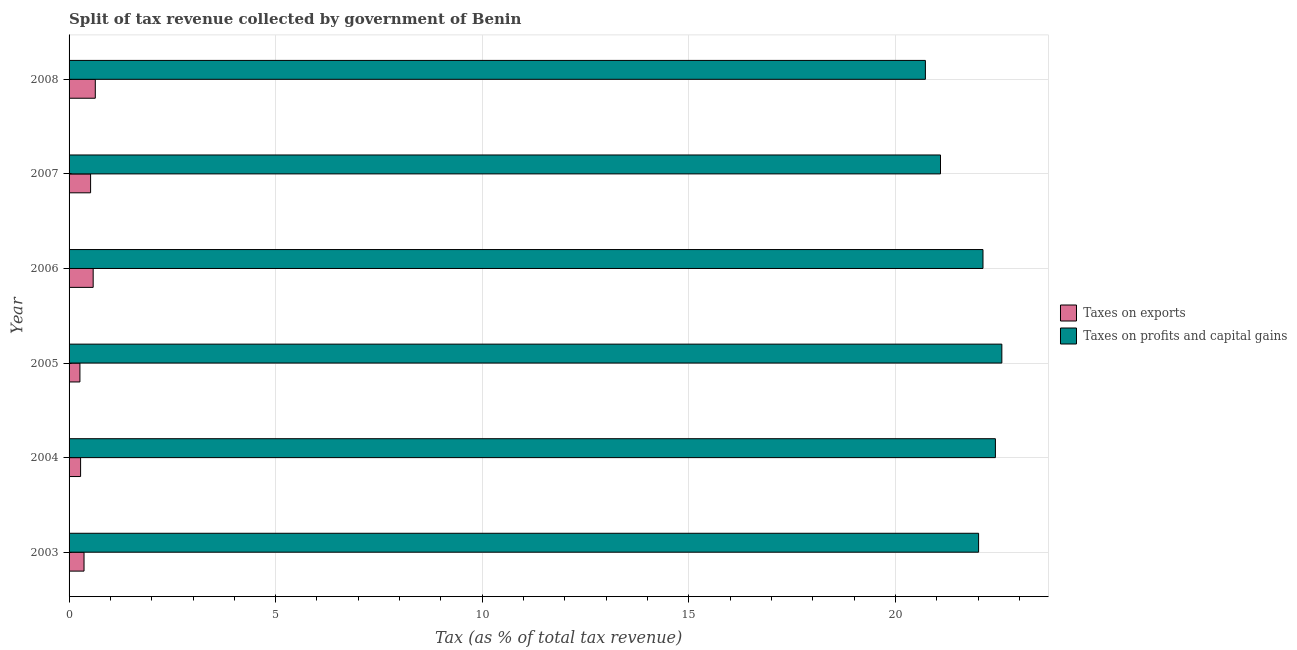How many groups of bars are there?
Ensure brevity in your answer.  6. Are the number of bars per tick equal to the number of legend labels?
Give a very brief answer. Yes. Are the number of bars on each tick of the Y-axis equal?
Offer a very short reply. Yes. How many bars are there on the 4th tick from the bottom?
Your answer should be compact. 2. In how many cases, is the number of bars for a given year not equal to the number of legend labels?
Your response must be concise. 0. What is the percentage of revenue obtained from taxes on exports in 2004?
Keep it short and to the point. 0.28. Across all years, what is the maximum percentage of revenue obtained from taxes on exports?
Provide a succinct answer. 0.63. Across all years, what is the minimum percentage of revenue obtained from taxes on exports?
Offer a terse response. 0.26. In which year was the percentage of revenue obtained from taxes on profits and capital gains maximum?
Your answer should be compact. 2005. In which year was the percentage of revenue obtained from taxes on profits and capital gains minimum?
Give a very brief answer. 2008. What is the total percentage of revenue obtained from taxes on exports in the graph?
Your answer should be very brief. 2.64. What is the difference between the percentage of revenue obtained from taxes on exports in 2003 and that in 2006?
Offer a very short reply. -0.22. What is the difference between the percentage of revenue obtained from taxes on profits and capital gains in 2008 and the percentage of revenue obtained from taxes on exports in 2007?
Keep it short and to the point. 20.2. What is the average percentage of revenue obtained from taxes on profits and capital gains per year?
Your answer should be compact. 21.82. In the year 2007, what is the difference between the percentage of revenue obtained from taxes on exports and percentage of revenue obtained from taxes on profits and capital gains?
Provide a succinct answer. -20.57. What is the ratio of the percentage of revenue obtained from taxes on profits and capital gains in 2006 to that in 2007?
Offer a very short reply. 1.05. Is the percentage of revenue obtained from taxes on exports in 2003 less than that in 2005?
Offer a terse response. No. What is the difference between the highest and the second highest percentage of revenue obtained from taxes on profits and capital gains?
Offer a very short reply. 0.16. What is the difference between the highest and the lowest percentage of revenue obtained from taxes on profits and capital gains?
Provide a succinct answer. 1.85. In how many years, is the percentage of revenue obtained from taxes on profits and capital gains greater than the average percentage of revenue obtained from taxes on profits and capital gains taken over all years?
Offer a terse response. 4. What does the 2nd bar from the top in 2004 represents?
Give a very brief answer. Taxes on exports. What does the 2nd bar from the bottom in 2008 represents?
Your response must be concise. Taxes on profits and capital gains. Are all the bars in the graph horizontal?
Your answer should be compact. Yes. Are the values on the major ticks of X-axis written in scientific E-notation?
Make the answer very short. No. Does the graph contain any zero values?
Give a very brief answer. No. Does the graph contain grids?
Keep it short and to the point. Yes. How many legend labels are there?
Keep it short and to the point. 2. What is the title of the graph?
Provide a succinct answer. Split of tax revenue collected by government of Benin. Does "Nitrous oxide" appear as one of the legend labels in the graph?
Your answer should be compact. No. What is the label or title of the X-axis?
Offer a very short reply. Tax (as % of total tax revenue). What is the Tax (as % of total tax revenue) of Taxes on exports in 2003?
Make the answer very short. 0.36. What is the Tax (as % of total tax revenue) in Taxes on profits and capital gains in 2003?
Provide a short and direct response. 22.01. What is the Tax (as % of total tax revenue) in Taxes on exports in 2004?
Your answer should be very brief. 0.28. What is the Tax (as % of total tax revenue) in Taxes on profits and capital gains in 2004?
Keep it short and to the point. 22.42. What is the Tax (as % of total tax revenue) of Taxes on exports in 2005?
Keep it short and to the point. 0.26. What is the Tax (as % of total tax revenue) of Taxes on profits and capital gains in 2005?
Ensure brevity in your answer.  22.58. What is the Tax (as % of total tax revenue) in Taxes on exports in 2006?
Offer a very short reply. 0.58. What is the Tax (as % of total tax revenue) of Taxes on profits and capital gains in 2006?
Provide a short and direct response. 22.12. What is the Tax (as % of total tax revenue) in Taxes on exports in 2007?
Offer a very short reply. 0.52. What is the Tax (as % of total tax revenue) of Taxes on profits and capital gains in 2007?
Give a very brief answer. 21.09. What is the Tax (as % of total tax revenue) in Taxes on exports in 2008?
Offer a terse response. 0.63. What is the Tax (as % of total tax revenue) of Taxes on profits and capital gains in 2008?
Provide a short and direct response. 20.73. Across all years, what is the maximum Tax (as % of total tax revenue) of Taxes on exports?
Ensure brevity in your answer.  0.63. Across all years, what is the maximum Tax (as % of total tax revenue) in Taxes on profits and capital gains?
Your response must be concise. 22.58. Across all years, what is the minimum Tax (as % of total tax revenue) of Taxes on exports?
Offer a very short reply. 0.26. Across all years, what is the minimum Tax (as % of total tax revenue) of Taxes on profits and capital gains?
Keep it short and to the point. 20.73. What is the total Tax (as % of total tax revenue) in Taxes on exports in the graph?
Give a very brief answer. 2.64. What is the total Tax (as % of total tax revenue) of Taxes on profits and capital gains in the graph?
Your answer should be compact. 130.94. What is the difference between the Tax (as % of total tax revenue) in Taxes on exports in 2003 and that in 2004?
Give a very brief answer. 0.08. What is the difference between the Tax (as % of total tax revenue) of Taxes on profits and capital gains in 2003 and that in 2004?
Your answer should be very brief. -0.41. What is the difference between the Tax (as % of total tax revenue) of Taxes on exports in 2003 and that in 2005?
Your response must be concise. 0.1. What is the difference between the Tax (as % of total tax revenue) in Taxes on profits and capital gains in 2003 and that in 2005?
Keep it short and to the point. -0.56. What is the difference between the Tax (as % of total tax revenue) in Taxes on exports in 2003 and that in 2006?
Your answer should be very brief. -0.22. What is the difference between the Tax (as % of total tax revenue) of Taxes on profits and capital gains in 2003 and that in 2006?
Ensure brevity in your answer.  -0.11. What is the difference between the Tax (as % of total tax revenue) of Taxes on exports in 2003 and that in 2007?
Give a very brief answer. -0.16. What is the difference between the Tax (as % of total tax revenue) of Taxes on profits and capital gains in 2003 and that in 2007?
Give a very brief answer. 0.92. What is the difference between the Tax (as % of total tax revenue) in Taxes on exports in 2003 and that in 2008?
Provide a short and direct response. -0.27. What is the difference between the Tax (as % of total tax revenue) of Taxes on profits and capital gains in 2003 and that in 2008?
Ensure brevity in your answer.  1.29. What is the difference between the Tax (as % of total tax revenue) of Taxes on exports in 2004 and that in 2005?
Keep it short and to the point. 0.02. What is the difference between the Tax (as % of total tax revenue) in Taxes on profits and capital gains in 2004 and that in 2005?
Your answer should be very brief. -0.16. What is the difference between the Tax (as % of total tax revenue) of Taxes on exports in 2004 and that in 2006?
Provide a succinct answer. -0.3. What is the difference between the Tax (as % of total tax revenue) of Taxes on profits and capital gains in 2004 and that in 2006?
Offer a very short reply. 0.3. What is the difference between the Tax (as % of total tax revenue) in Taxes on exports in 2004 and that in 2007?
Offer a terse response. -0.24. What is the difference between the Tax (as % of total tax revenue) of Taxes on profits and capital gains in 2004 and that in 2007?
Make the answer very short. 1.33. What is the difference between the Tax (as % of total tax revenue) of Taxes on exports in 2004 and that in 2008?
Keep it short and to the point. -0.36. What is the difference between the Tax (as % of total tax revenue) of Taxes on profits and capital gains in 2004 and that in 2008?
Provide a short and direct response. 1.69. What is the difference between the Tax (as % of total tax revenue) of Taxes on exports in 2005 and that in 2006?
Make the answer very short. -0.32. What is the difference between the Tax (as % of total tax revenue) of Taxes on profits and capital gains in 2005 and that in 2006?
Give a very brief answer. 0.46. What is the difference between the Tax (as % of total tax revenue) in Taxes on exports in 2005 and that in 2007?
Give a very brief answer. -0.26. What is the difference between the Tax (as % of total tax revenue) in Taxes on profits and capital gains in 2005 and that in 2007?
Your answer should be compact. 1.48. What is the difference between the Tax (as % of total tax revenue) of Taxes on exports in 2005 and that in 2008?
Provide a short and direct response. -0.37. What is the difference between the Tax (as % of total tax revenue) of Taxes on profits and capital gains in 2005 and that in 2008?
Your answer should be very brief. 1.85. What is the difference between the Tax (as % of total tax revenue) in Taxes on exports in 2006 and that in 2007?
Your answer should be compact. 0.06. What is the difference between the Tax (as % of total tax revenue) in Taxes on profits and capital gains in 2006 and that in 2007?
Keep it short and to the point. 1.03. What is the difference between the Tax (as % of total tax revenue) of Taxes on exports in 2006 and that in 2008?
Your response must be concise. -0.05. What is the difference between the Tax (as % of total tax revenue) in Taxes on profits and capital gains in 2006 and that in 2008?
Give a very brief answer. 1.39. What is the difference between the Tax (as % of total tax revenue) of Taxes on exports in 2007 and that in 2008?
Your answer should be compact. -0.11. What is the difference between the Tax (as % of total tax revenue) of Taxes on profits and capital gains in 2007 and that in 2008?
Your answer should be very brief. 0.37. What is the difference between the Tax (as % of total tax revenue) in Taxes on exports in 2003 and the Tax (as % of total tax revenue) in Taxes on profits and capital gains in 2004?
Offer a terse response. -22.06. What is the difference between the Tax (as % of total tax revenue) in Taxes on exports in 2003 and the Tax (as % of total tax revenue) in Taxes on profits and capital gains in 2005?
Keep it short and to the point. -22.21. What is the difference between the Tax (as % of total tax revenue) in Taxes on exports in 2003 and the Tax (as % of total tax revenue) in Taxes on profits and capital gains in 2006?
Ensure brevity in your answer.  -21.76. What is the difference between the Tax (as % of total tax revenue) of Taxes on exports in 2003 and the Tax (as % of total tax revenue) of Taxes on profits and capital gains in 2007?
Keep it short and to the point. -20.73. What is the difference between the Tax (as % of total tax revenue) of Taxes on exports in 2003 and the Tax (as % of total tax revenue) of Taxes on profits and capital gains in 2008?
Your answer should be very brief. -20.36. What is the difference between the Tax (as % of total tax revenue) in Taxes on exports in 2004 and the Tax (as % of total tax revenue) in Taxes on profits and capital gains in 2005?
Ensure brevity in your answer.  -22.3. What is the difference between the Tax (as % of total tax revenue) in Taxes on exports in 2004 and the Tax (as % of total tax revenue) in Taxes on profits and capital gains in 2006?
Provide a short and direct response. -21.84. What is the difference between the Tax (as % of total tax revenue) of Taxes on exports in 2004 and the Tax (as % of total tax revenue) of Taxes on profits and capital gains in 2007?
Your answer should be compact. -20.81. What is the difference between the Tax (as % of total tax revenue) of Taxes on exports in 2004 and the Tax (as % of total tax revenue) of Taxes on profits and capital gains in 2008?
Offer a very short reply. -20.45. What is the difference between the Tax (as % of total tax revenue) in Taxes on exports in 2005 and the Tax (as % of total tax revenue) in Taxes on profits and capital gains in 2006?
Provide a short and direct response. -21.86. What is the difference between the Tax (as % of total tax revenue) of Taxes on exports in 2005 and the Tax (as % of total tax revenue) of Taxes on profits and capital gains in 2007?
Ensure brevity in your answer.  -20.83. What is the difference between the Tax (as % of total tax revenue) of Taxes on exports in 2005 and the Tax (as % of total tax revenue) of Taxes on profits and capital gains in 2008?
Provide a succinct answer. -20.46. What is the difference between the Tax (as % of total tax revenue) of Taxes on exports in 2006 and the Tax (as % of total tax revenue) of Taxes on profits and capital gains in 2007?
Offer a very short reply. -20.51. What is the difference between the Tax (as % of total tax revenue) in Taxes on exports in 2006 and the Tax (as % of total tax revenue) in Taxes on profits and capital gains in 2008?
Your answer should be very brief. -20.14. What is the difference between the Tax (as % of total tax revenue) of Taxes on exports in 2007 and the Tax (as % of total tax revenue) of Taxes on profits and capital gains in 2008?
Your answer should be very brief. -20.2. What is the average Tax (as % of total tax revenue) in Taxes on exports per year?
Your response must be concise. 0.44. What is the average Tax (as % of total tax revenue) of Taxes on profits and capital gains per year?
Your answer should be very brief. 21.82. In the year 2003, what is the difference between the Tax (as % of total tax revenue) in Taxes on exports and Tax (as % of total tax revenue) in Taxes on profits and capital gains?
Offer a very short reply. -21.65. In the year 2004, what is the difference between the Tax (as % of total tax revenue) of Taxes on exports and Tax (as % of total tax revenue) of Taxes on profits and capital gains?
Your response must be concise. -22.14. In the year 2005, what is the difference between the Tax (as % of total tax revenue) of Taxes on exports and Tax (as % of total tax revenue) of Taxes on profits and capital gains?
Your answer should be compact. -22.31. In the year 2006, what is the difference between the Tax (as % of total tax revenue) in Taxes on exports and Tax (as % of total tax revenue) in Taxes on profits and capital gains?
Offer a terse response. -21.54. In the year 2007, what is the difference between the Tax (as % of total tax revenue) of Taxes on exports and Tax (as % of total tax revenue) of Taxes on profits and capital gains?
Your answer should be compact. -20.57. In the year 2008, what is the difference between the Tax (as % of total tax revenue) in Taxes on exports and Tax (as % of total tax revenue) in Taxes on profits and capital gains?
Your answer should be compact. -20.09. What is the ratio of the Tax (as % of total tax revenue) in Taxes on exports in 2003 to that in 2004?
Ensure brevity in your answer.  1.3. What is the ratio of the Tax (as % of total tax revenue) of Taxes on profits and capital gains in 2003 to that in 2004?
Provide a succinct answer. 0.98. What is the ratio of the Tax (as % of total tax revenue) in Taxes on exports in 2003 to that in 2005?
Your answer should be very brief. 1.38. What is the ratio of the Tax (as % of total tax revenue) of Taxes on profits and capital gains in 2003 to that in 2005?
Provide a succinct answer. 0.98. What is the ratio of the Tax (as % of total tax revenue) in Taxes on exports in 2003 to that in 2006?
Offer a terse response. 0.62. What is the ratio of the Tax (as % of total tax revenue) in Taxes on profits and capital gains in 2003 to that in 2006?
Your answer should be very brief. 1. What is the ratio of the Tax (as % of total tax revenue) of Taxes on exports in 2003 to that in 2007?
Your answer should be compact. 0.7. What is the ratio of the Tax (as % of total tax revenue) of Taxes on profits and capital gains in 2003 to that in 2007?
Provide a short and direct response. 1.04. What is the ratio of the Tax (as % of total tax revenue) in Taxes on exports in 2003 to that in 2008?
Make the answer very short. 0.57. What is the ratio of the Tax (as % of total tax revenue) of Taxes on profits and capital gains in 2003 to that in 2008?
Your response must be concise. 1.06. What is the ratio of the Tax (as % of total tax revenue) of Taxes on exports in 2004 to that in 2005?
Your answer should be very brief. 1.06. What is the ratio of the Tax (as % of total tax revenue) in Taxes on profits and capital gains in 2004 to that in 2005?
Provide a succinct answer. 0.99. What is the ratio of the Tax (as % of total tax revenue) of Taxes on exports in 2004 to that in 2006?
Make the answer very short. 0.48. What is the ratio of the Tax (as % of total tax revenue) in Taxes on profits and capital gains in 2004 to that in 2006?
Provide a short and direct response. 1.01. What is the ratio of the Tax (as % of total tax revenue) of Taxes on exports in 2004 to that in 2007?
Ensure brevity in your answer.  0.54. What is the ratio of the Tax (as % of total tax revenue) in Taxes on profits and capital gains in 2004 to that in 2007?
Your answer should be compact. 1.06. What is the ratio of the Tax (as % of total tax revenue) of Taxes on exports in 2004 to that in 2008?
Offer a very short reply. 0.44. What is the ratio of the Tax (as % of total tax revenue) of Taxes on profits and capital gains in 2004 to that in 2008?
Ensure brevity in your answer.  1.08. What is the ratio of the Tax (as % of total tax revenue) in Taxes on exports in 2005 to that in 2006?
Ensure brevity in your answer.  0.45. What is the ratio of the Tax (as % of total tax revenue) in Taxes on profits and capital gains in 2005 to that in 2006?
Give a very brief answer. 1.02. What is the ratio of the Tax (as % of total tax revenue) in Taxes on exports in 2005 to that in 2007?
Give a very brief answer. 0.5. What is the ratio of the Tax (as % of total tax revenue) in Taxes on profits and capital gains in 2005 to that in 2007?
Offer a very short reply. 1.07. What is the ratio of the Tax (as % of total tax revenue) in Taxes on exports in 2005 to that in 2008?
Your answer should be compact. 0.41. What is the ratio of the Tax (as % of total tax revenue) of Taxes on profits and capital gains in 2005 to that in 2008?
Provide a short and direct response. 1.09. What is the ratio of the Tax (as % of total tax revenue) in Taxes on exports in 2006 to that in 2007?
Provide a succinct answer. 1.12. What is the ratio of the Tax (as % of total tax revenue) of Taxes on profits and capital gains in 2006 to that in 2007?
Give a very brief answer. 1.05. What is the ratio of the Tax (as % of total tax revenue) of Taxes on exports in 2006 to that in 2008?
Offer a terse response. 0.92. What is the ratio of the Tax (as % of total tax revenue) of Taxes on profits and capital gains in 2006 to that in 2008?
Offer a terse response. 1.07. What is the ratio of the Tax (as % of total tax revenue) in Taxes on exports in 2007 to that in 2008?
Provide a succinct answer. 0.82. What is the ratio of the Tax (as % of total tax revenue) in Taxes on profits and capital gains in 2007 to that in 2008?
Provide a short and direct response. 1.02. What is the difference between the highest and the second highest Tax (as % of total tax revenue) of Taxes on exports?
Ensure brevity in your answer.  0.05. What is the difference between the highest and the second highest Tax (as % of total tax revenue) in Taxes on profits and capital gains?
Your answer should be compact. 0.16. What is the difference between the highest and the lowest Tax (as % of total tax revenue) in Taxes on exports?
Your answer should be very brief. 0.37. What is the difference between the highest and the lowest Tax (as % of total tax revenue) in Taxes on profits and capital gains?
Keep it short and to the point. 1.85. 